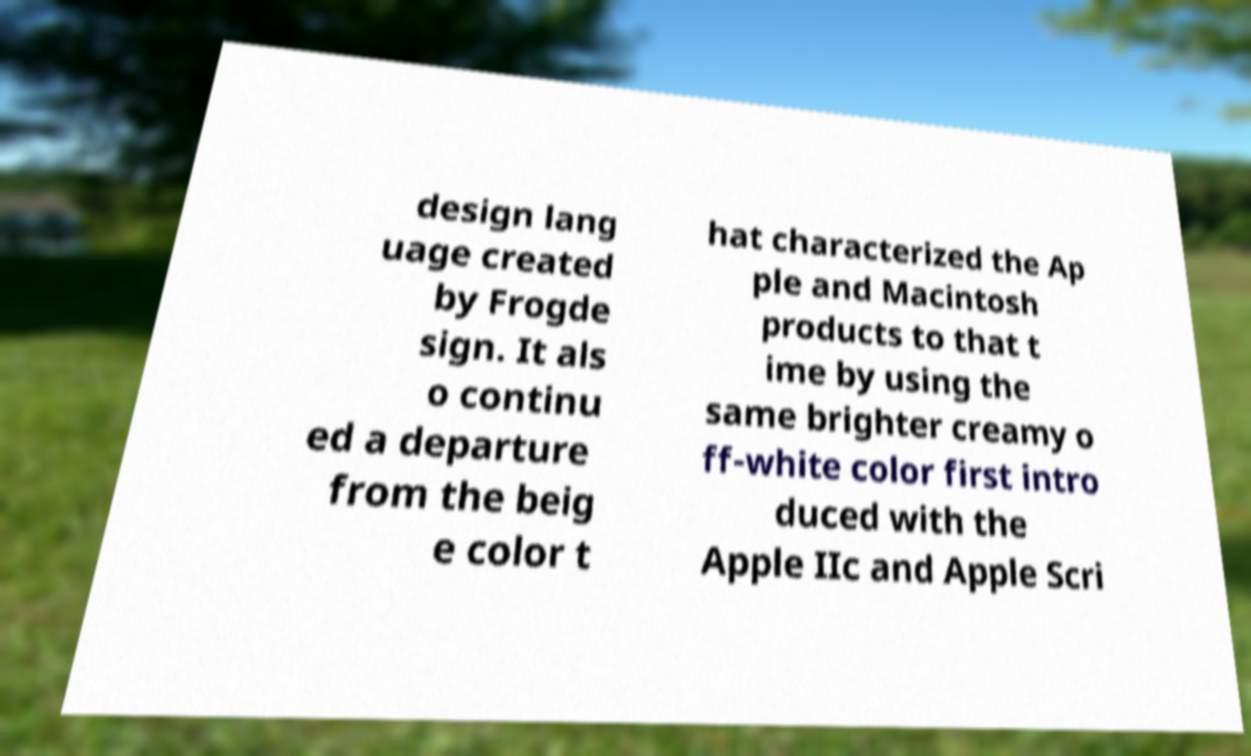Could you assist in decoding the text presented in this image and type it out clearly? design lang uage created by Frogde sign. It als o continu ed a departure from the beig e color t hat characterized the Ap ple and Macintosh products to that t ime by using the same brighter creamy o ff-white color first intro duced with the Apple IIc and Apple Scri 